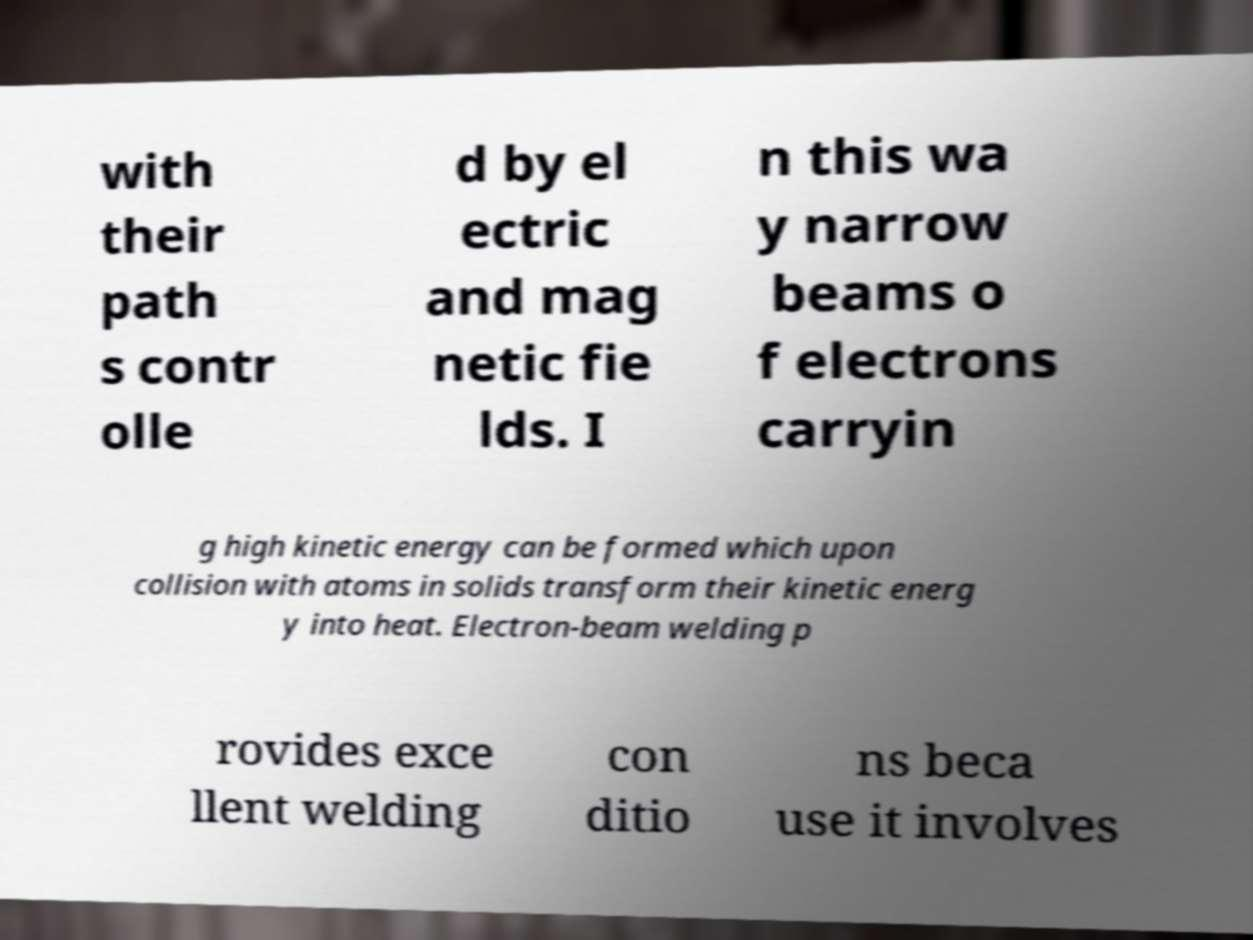Can you read and provide the text displayed in the image?This photo seems to have some interesting text. Can you extract and type it out for me? with their path s contr olle d by el ectric and mag netic fie lds. I n this wa y narrow beams o f electrons carryin g high kinetic energy can be formed which upon collision with atoms in solids transform their kinetic energ y into heat. Electron-beam welding p rovides exce llent welding con ditio ns beca use it involves 